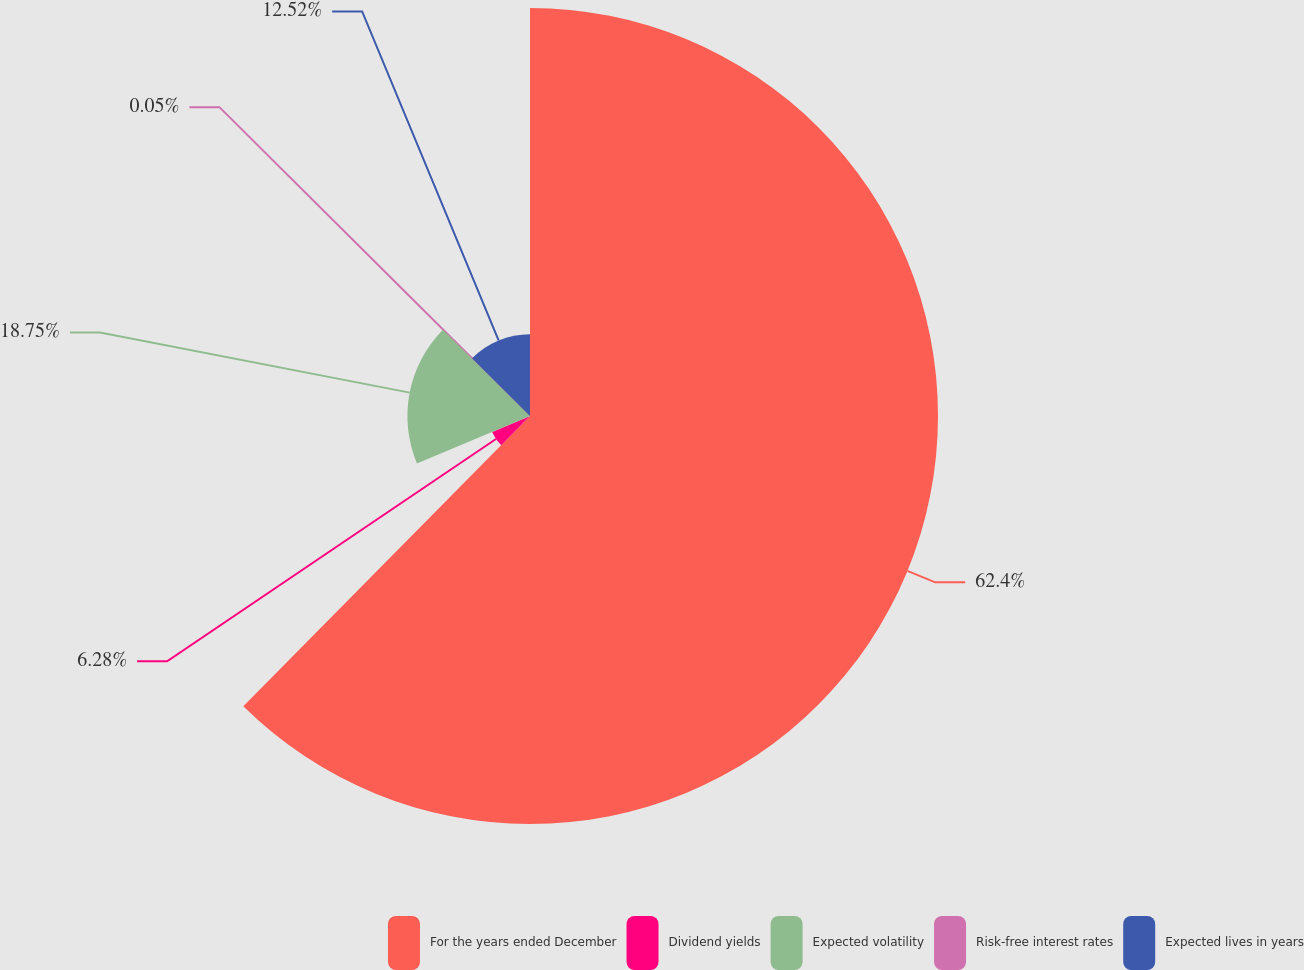Convert chart to OTSL. <chart><loc_0><loc_0><loc_500><loc_500><pie_chart><fcel>For the years ended December<fcel>Dividend yields<fcel>Expected volatility<fcel>Risk-free interest rates<fcel>Expected lives in years<nl><fcel>62.4%<fcel>6.28%<fcel>18.75%<fcel>0.05%<fcel>12.52%<nl></chart> 